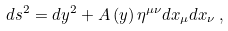<formula> <loc_0><loc_0><loc_500><loc_500>d s ^ { 2 } = d y ^ { 2 } + A \left ( y \right ) \eta ^ { \mu \nu } d x _ { \mu } d x _ { \nu } \, ,</formula> 